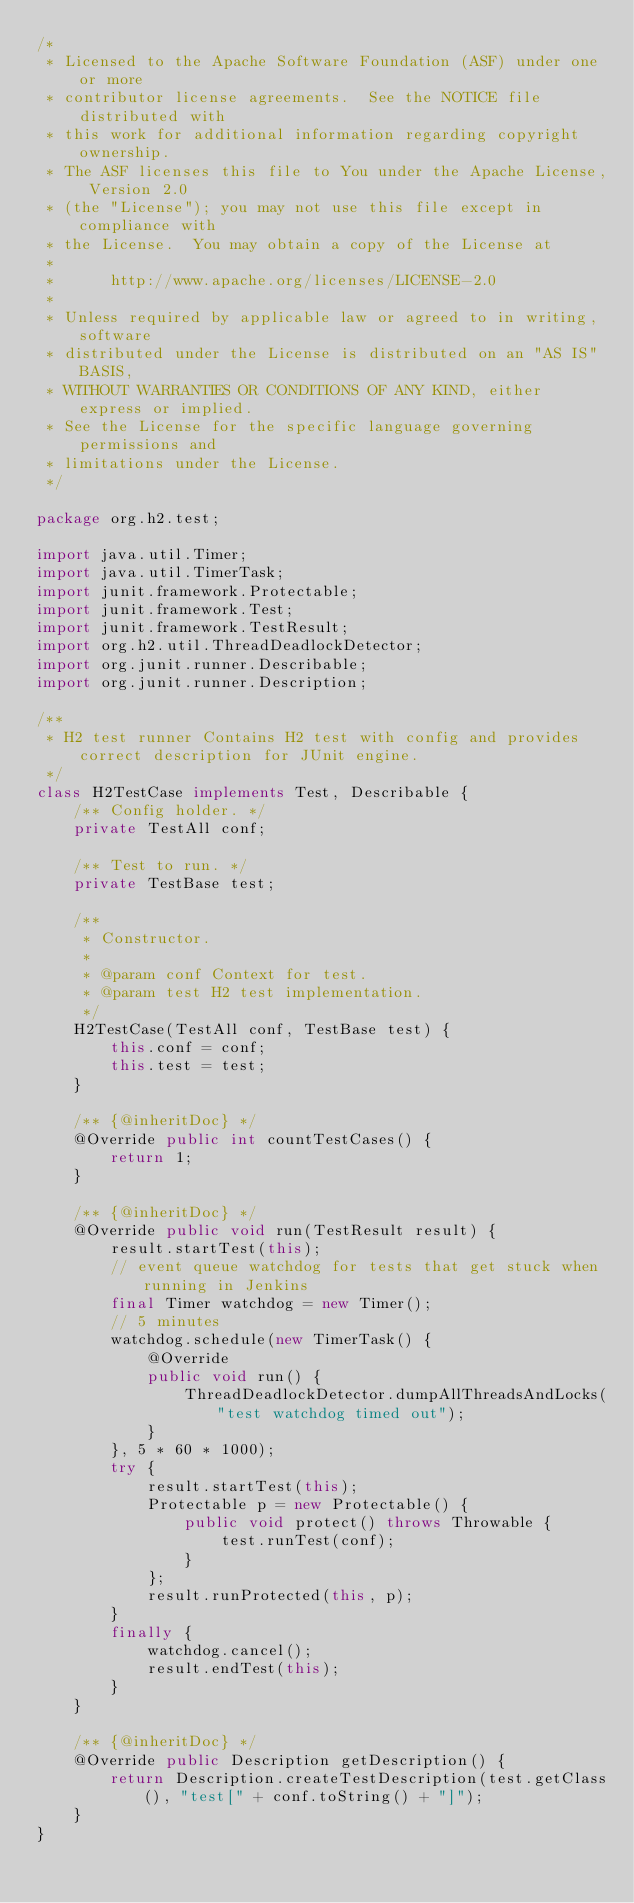Convert code to text. <code><loc_0><loc_0><loc_500><loc_500><_Java_>/*
 * Licensed to the Apache Software Foundation (ASF) under one or more
 * contributor license agreements.  See the NOTICE file distributed with
 * this work for additional information regarding copyright ownership.
 * The ASF licenses this file to You under the Apache License, Version 2.0
 * (the "License"); you may not use this file except in compliance with
 * the License.  You may obtain a copy of the License at
 *
 *      http://www.apache.org/licenses/LICENSE-2.0
 *
 * Unless required by applicable law or agreed to in writing, software
 * distributed under the License is distributed on an "AS IS" BASIS,
 * WITHOUT WARRANTIES OR CONDITIONS OF ANY KIND, either express or implied.
 * See the License for the specific language governing permissions and
 * limitations under the License.
 */

package org.h2.test;

import java.util.Timer;
import java.util.TimerTask;
import junit.framework.Protectable;
import junit.framework.Test;
import junit.framework.TestResult;
import org.h2.util.ThreadDeadlockDetector;
import org.junit.runner.Describable;
import org.junit.runner.Description;

/**
 * H2 test runner Contains H2 test with config and provides correct description for JUnit engine.
 */
class H2TestCase implements Test, Describable {
    /** Config holder. */
    private TestAll conf;

    /** Test to run. */
    private TestBase test;

    /**
     * Constructor.
     *
     * @param conf Context for test.
     * @param test H2 test implementation.
     */
    H2TestCase(TestAll conf, TestBase test) {
        this.conf = conf;
        this.test = test;
    }

    /** {@inheritDoc} */
    @Override public int countTestCases() {
        return 1;
    }

    /** {@inheritDoc} */
    @Override public void run(TestResult result) {
        result.startTest(this);
        // event queue watchdog for tests that get stuck when running in Jenkins
        final Timer watchdog = new Timer();
        // 5 minutes
        watchdog.schedule(new TimerTask() {
            @Override
            public void run() {
                ThreadDeadlockDetector.dumpAllThreadsAndLocks("test watchdog timed out");
            }
        }, 5 * 60 * 1000);
        try {
            result.startTest(this);
            Protectable p = new Protectable() {
                public void protect() throws Throwable {
                    test.runTest(conf);
                }
            };
            result.runProtected(this, p);
        }
        finally {
            watchdog.cancel();
            result.endTest(this);
        }
    }

    /** {@inheritDoc} */
    @Override public Description getDescription() {
        return Description.createTestDescription(test.getClass(), "test[" + conf.toString() + "]");
    }
}
</code> 